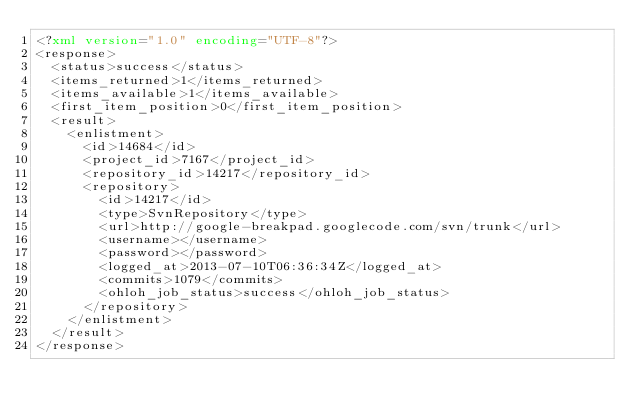Convert code to text. <code><loc_0><loc_0><loc_500><loc_500><_XML_><?xml version="1.0" encoding="UTF-8"?>
<response>
  <status>success</status>
  <items_returned>1</items_returned>
  <items_available>1</items_available>
  <first_item_position>0</first_item_position>
  <result>
    <enlistment>
      <id>14684</id>
      <project_id>7167</project_id>
      <repository_id>14217</repository_id>
      <repository>
        <id>14217</id>
        <type>SvnRepository</type>
        <url>http://google-breakpad.googlecode.com/svn/trunk</url>
        <username></username>
        <password></password>
        <logged_at>2013-07-10T06:36:34Z</logged_at>
        <commits>1079</commits>
        <ohloh_job_status>success</ohloh_job_status>
      </repository>
    </enlistment>
  </result>
</response>
</code> 